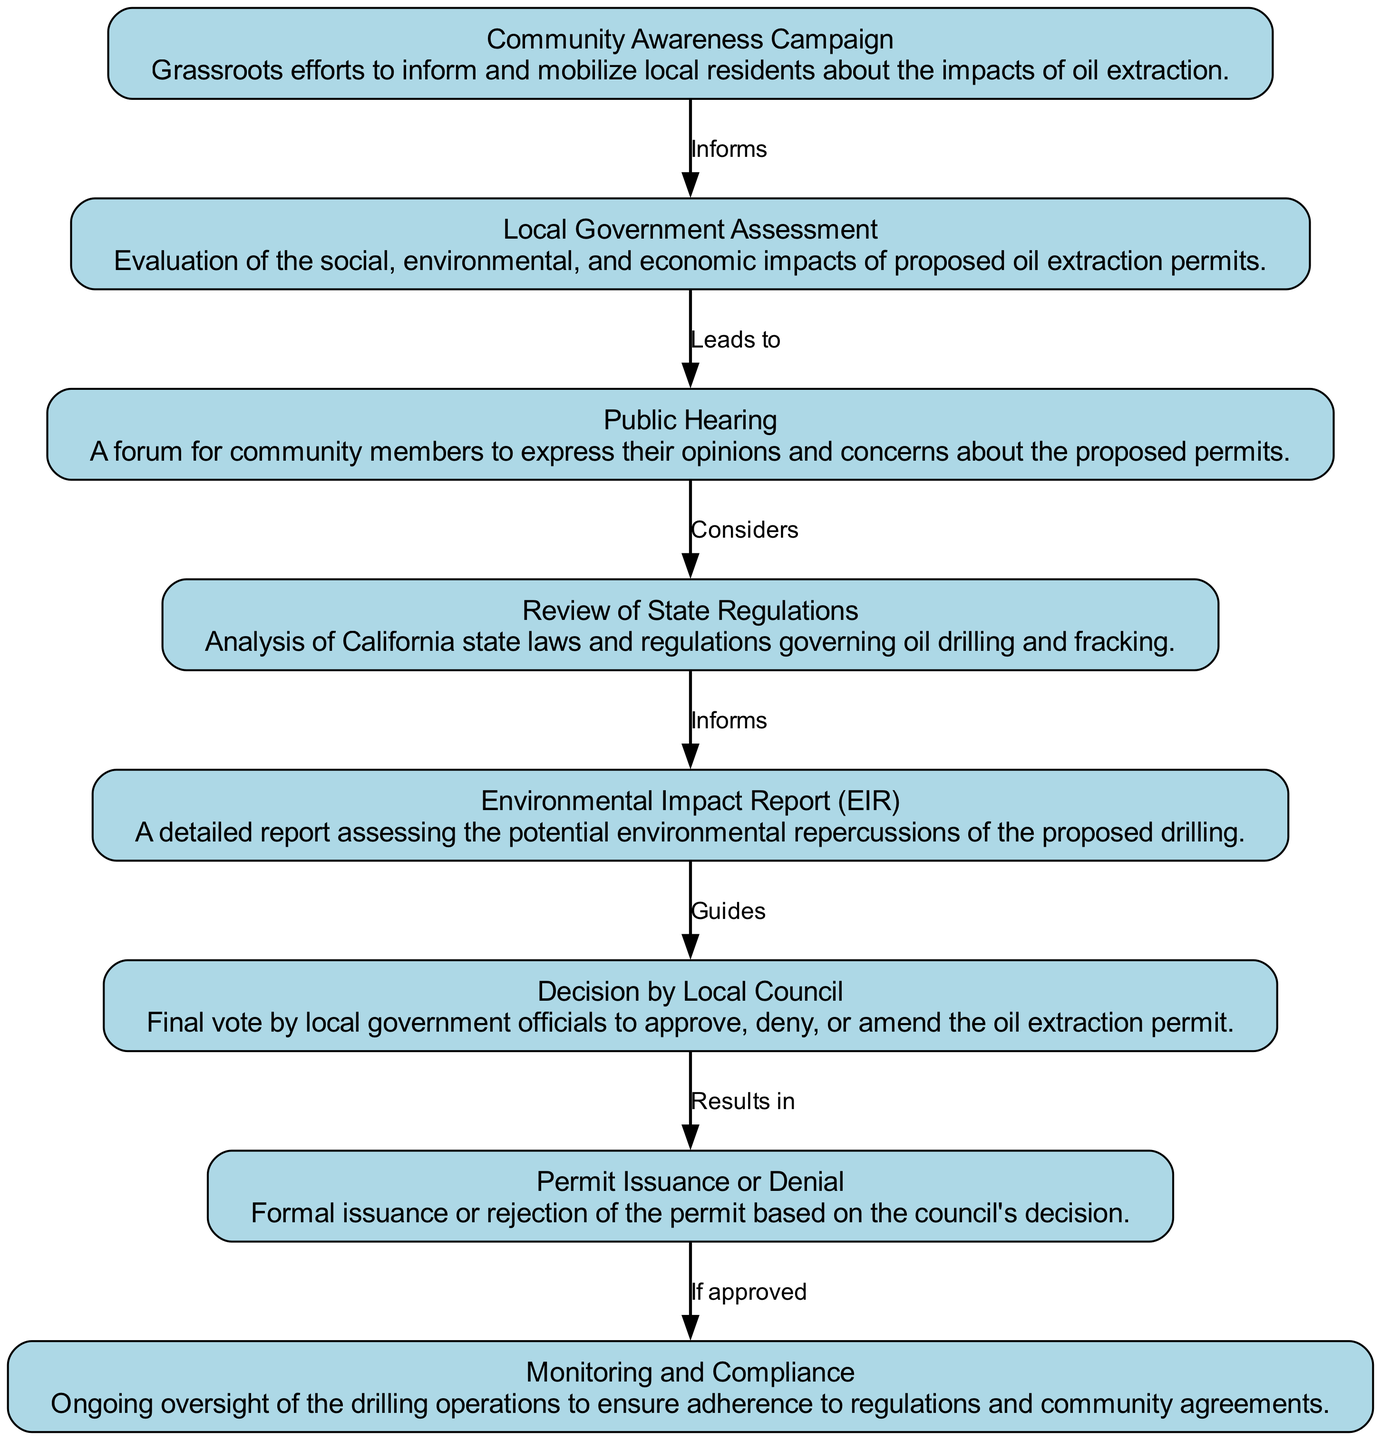What is the first step in the process? The first step in the process is shown by the node labeled "Community Awareness Campaign." It indicates that grassroots efforts to inform and mobilize local residents about the impacts of oil extraction begin the decision-making flow.
Answer: Community Awareness Campaign How many nodes are present in the diagram? By counting the individual nodes that represent elements of the decision-making process, we find a total of eight nodes listed. Each node corresponds to a specific step in the process.
Answer: 8 Which node leads to the Public Hearing? The node that directly precedes the Public Hearing node is "Local Government Assessment." This shows that the assessment leads to a public forum for community expression.
Answer: Local Government Assessment What is the relationship between the Environmental Impact Report and the Decision by Local Council? The arrow from the "Environmental Impact Report" node to the "Decision by Local Council" node indicates that the EIR guides the final decision made by local government officials regarding the permit approval.
Answer: Guides If the oil extraction permit is denied, what happens next? According to the flowchart, if the permit is denied, there is no issuance of the permit, which indicates that the process ends with denial without further action.
Answer: Formal rejection of the permit What step comes after the Public Hearing? The flowchart shows that the step following the Public Hearing is the "Review of State Regulations," indicating that community input is considered within the context of relevant state laws.
Answer: Review of State Regulations What is the final outcome of the process? The final outcome, represented by the last node in the flow, indicates that the process results in "Permit Issuance or Denial," which captures the decision reached by the local council after evaluating all pertinent factors.
Answer: Permit Issuance or Denial What does the Monitoring and Compliance node ensure? The Monitoring and Compliance node signifies ongoing oversight of drilling operations, which ensures adherence to regulations and community agreements following permit decisions.
Answer: Ongoing oversight 